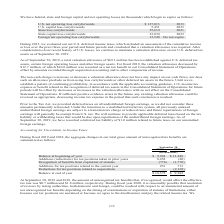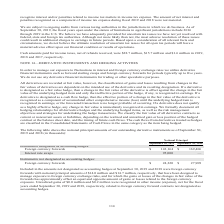According to Cubic's financial document, What is the balance at end of year for 2019? According to the financial document, $18,575 (in thousands). The relevant text states: "o acquisitions — (2,169) Balance at end of year $ 18,575 $ 9,942..." Also, What is the cash amount paid for income taxes, net of refunds received in 2019? According to the financial document, $28.7 million. The relevant text states: "id for income taxes, net of refunds received, were $28.7 million, $15.7 million and $1.6 million in 2019, 2018 and 2017, respectively. NOTE 14—DERIVATIVE INSTRUMENT..." Also, In the table of aggregate changes in the total gross amount of unrecognized tax benefits, which items concern Additions? The document shows two values: Additions (reductions) for tax positions taken in prior years and Additions for tax positions related to the current year. From the document: "Balance at beginning of year $ 9,942 $ 13,248 Additions (reductions) for tax positions taken in prior years 8,458 (80) enefits from expiration of stat..." Also, can you calculate: What is the total cash amounts paid for income taxes, net of refunds received in 2017, 2018 and 2019? Based on the calculation: 28.7+15.7+1.6, the result is 46 (in millions). This is based on the information: "received, were $28.7 million, $15.7 million and $1.6 million in 2019, 2018 and 2017, respectively. NOTE 14—DERIVATIVE INSTRUMENTS AND HEDGING ACTIVITIES for income taxes, net of refunds received, were..." The key data points involved are: 1.6, 15.7, 28.7. Also, can you calculate: What is the percentage change in additions for tax positions related to the current year in 2019 from 2018? To answer this question, I need to perform calculations using the financial data. The calculation is: (951-713)/713, which equals 33.38 (percentage). This is based on the information: "for tax positions related to the current year 951 713 ons for tax positions related to the current year 951 713..." The key data points involved are: 713, 951. Additionally, In which year was the amount of unrecognized tax benefits higher? According to the financial document, 2018. The relevant text states: "ncertainty in Income Taxes During fiscal 2019 and 2018, the aggregate changes in our total gross amount of unrecognized tax benefits are summarized as fol ncertainty in Income Taxes During fiscal 2019..." 